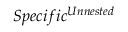<formula> <loc_0><loc_0><loc_500><loc_500>S p e c i f i c ^ { U n n e s t e d }</formula> 